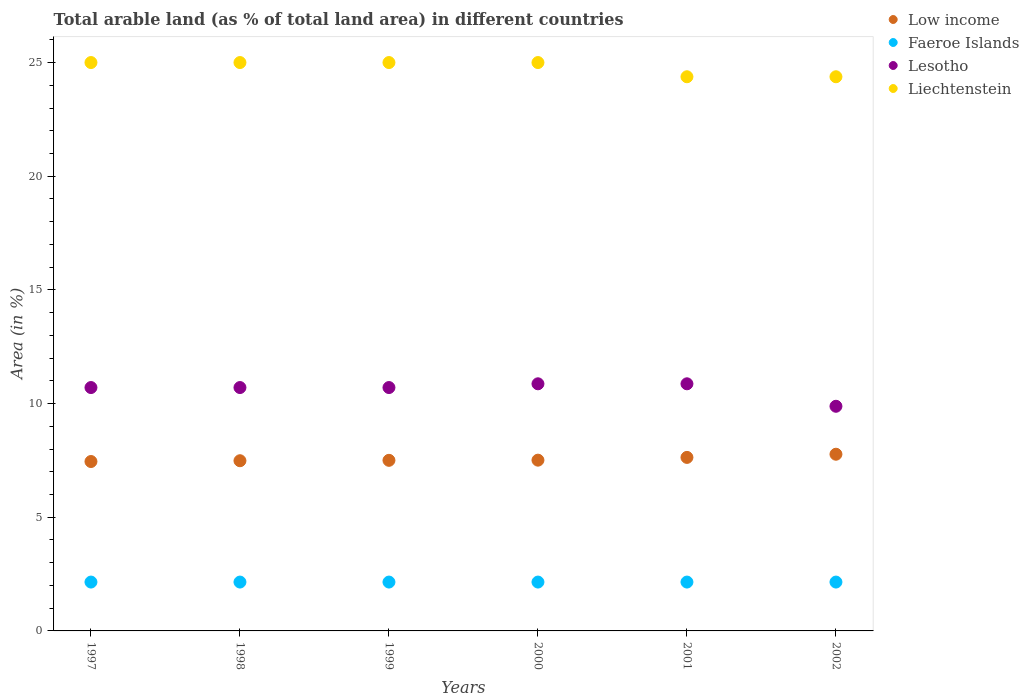How many different coloured dotlines are there?
Offer a terse response. 4. Is the number of dotlines equal to the number of legend labels?
Make the answer very short. Yes. What is the percentage of arable land in Low income in 1998?
Your answer should be compact. 7.49. Across all years, what is the maximum percentage of arable land in Lesotho?
Offer a very short reply. 10.87. Across all years, what is the minimum percentage of arable land in Faeroe Islands?
Your response must be concise. 2.15. In which year was the percentage of arable land in Lesotho maximum?
Offer a terse response. 2000. In which year was the percentage of arable land in Low income minimum?
Your answer should be compact. 1997. What is the total percentage of arable land in Lesotho in the graph?
Your answer should be very brief. 63.74. What is the difference between the percentage of arable land in Low income in 1997 and that in 2001?
Offer a terse response. -0.18. What is the difference between the percentage of arable land in Low income in 1997 and the percentage of arable land in Liechtenstein in 2001?
Provide a short and direct response. -16.92. What is the average percentage of arable land in Lesotho per year?
Provide a succinct answer. 10.62. In the year 1999, what is the difference between the percentage of arable land in Lesotho and percentage of arable land in Faeroe Islands?
Keep it short and to the point. 8.56. In how many years, is the percentage of arable land in Faeroe Islands greater than 16 %?
Offer a terse response. 0. What is the ratio of the percentage of arable land in Low income in 2000 to that in 2001?
Make the answer very short. 0.98. Is the difference between the percentage of arable land in Lesotho in 1998 and 2002 greater than the difference between the percentage of arable land in Faeroe Islands in 1998 and 2002?
Make the answer very short. Yes. What is the difference between the highest and the second highest percentage of arable land in Faeroe Islands?
Offer a terse response. 0. In how many years, is the percentage of arable land in Liechtenstein greater than the average percentage of arable land in Liechtenstein taken over all years?
Offer a very short reply. 4. Is the sum of the percentage of arable land in Liechtenstein in 1999 and 2000 greater than the maximum percentage of arable land in Faeroe Islands across all years?
Give a very brief answer. Yes. Is it the case that in every year, the sum of the percentage of arable land in Low income and percentage of arable land in Faeroe Islands  is greater than the percentage of arable land in Lesotho?
Offer a very short reply. No. Is the percentage of arable land in Faeroe Islands strictly greater than the percentage of arable land in Low income over the years?
Provide a short and direct response. No. Is the percentage of arable land in Low income strictly less than the percentage of arable land in Lesotho over the years?
Ensure brevity in your answer.  Yes. How many years are there in the graph?
Offer a terse response. 6. What is the difference between two consecutive major ticks on the Y-axis?
Provide a succinct answer. 5. Are the values on the major ticks of Y-axis written in scientific E-notation?
Your answer should be very brief. No. Does the graph contain any zero values?
Your answer should be very brief. No. Where does the legend appear in the graph?
Keep it short and to the point. Top right. What is the title of the graph?
Provide a short and direct response. Total arable land (as % of total land area) in different countries. What is the label or title of the X-axis?
Ensure brevity in your answer.  Years. What is the label or title of the Y-axis?
Provide a short and direct response. Area (in %). What is the Area (in %) of Low income in 1997?
Offer a very short reply. 7.45. What is the Area (in %) of Faeroe Islands in 1997?
Your response must be concise. 2.15. What is the Area (in %) of Lesotho in 1997?
Give a very brief answer. 10.7. What is the Area (in %) in Liechtenstein in 1997?
Provide a succinct answer. 25. What is the Area (in %) in Low income in 1998?
Provide a succinct answer. 7.49. What is the Area (in %) of Faeroe Islands in 1998?
Provide a succinct answer. 2.15. What is the Area (in %) in Lesotho in 1998?
Your response must be concise. 10.7. What is the Area (in %) in Liechtenstein in 1998?
Keep it short and to the point. 25. What is the Area (in %) of Low income in 1999?
Provide a short and direct response. 7.5. What is the Area (in %) of Faeroe Islands in 1999?
Your response must be concise. 2.15. What is the Area (in %) of Lesotho in 1999?
Your answer should be very brief. 10.7. What is the Area (in %) in Liechtenstein in 1999?
Your answer should be compact. 25. What is the Area (in %) of Low income in 2000?
Keep it short and to the point. 7.51. What is the Area (in %) in Faeroe Islands in 2000?
Offer a very short reply. 2.15. What is the Area (in %) of Lesotho in 2000?
Offer a terse response. 10.87. What is the Area (in %) in Low income in 2001?
Offer a very short reply. 7.63. What is the Area (in %) of Faeroe Islands in 2001?
Offer a terse response. 2.15. What is the Area (in %) of Lesotho in 2001?
Offer a terse response. 10.87. What is the Area (in %) of Liechtenstein in 2001?
Give a very brief answer. 24.38. What is the Area (in %) of Low income in 2002?
Offer a terse response. 7.77. What is the Area (in %) in Faeroe Islands in 2002?
Provide a short and direct response. 2.15. What is the Area (in %) of Lesotho in 2002?
Your answer should be compact. 9.88. What is the Area (in %) in Liechtenstein in 2002?
Your answer should be very brief. 24.38. Across all years, what is the maximum Area (in %) of Low income?
Ensure brevity in your answer.  7.77. Across all years, what is the maximum Area (in %) in Faeroe Islands?
Keep it short and to the point. 2.15. Across all years, what is the maximum Area (in %) in Lesotho?
Your answer should be very brief. 10.87. Across all years, what is the maximum Area (in %) of Liechtenstein?
Provide a short and direct response. 25. Across all years, what is the minimum Area (in %) in Low income?
Provide a short and direct response. 7.45. Across all years, what is the minimum Area (in %) in Faeroe Islands?
Provide a succinct answer. 2.15. Across all years, what is the minimum Area (in %) of Lesotho?
Your answer should be very brief. 9.88. Across all years, what is the minimum Area (in %) of Liechtenstein?
Give a very brief answer. 24.38. What is the total Area (in %) of Low income in the graph?
Your answer should be compact. 45.36. What is the total Area (in %) of Faeroe Islands in the graph?
Keep it short and to the point. 12.89. What is the total Area (in %) of Lesotho in the graph?
Make the answer very short. 63.74. What is the total Area (in %) in Liechtenstein in the graph?
Provide a succinct answer. 148.75. What is the difference between the Area (in %) of Low income in 1997 and that in 1998?
Offer a very short reply. -0.03. What is the difference between the Area (in %) in Faeroe Islands in 1997 and that in 1998?
Offer a terse response. 0. What is the difference between the Area (in %) of Liechtenstein in 1997 and that in 1998?
Your response must be concise. 0. What is the difference between the Area (in %) of Low income in 1997 and that in 1999?
Give a very brief answer. -0.05. What is the difference between the Area (in %) of Faeroe Islands in 1997 and that in 1999?
Ensure brevity in your answer.  0. What is the difference between the Area (in %) of Low income in 1997 and that in 2000?
Offer a very short reply. -0.06. What is the difference between the Area (in %) of Faeroe Islands in 1997 and that in 2000?
Provide a short and direct response. 0. What is the difference between the Area (in %) of Lesotho in 1997 and that in 2000?
Make the answer very short. -0.16. What is the difference between the Area (in %) in Liechtenstein in 1997 and that in 2000?
Keep it short and to the point. 0. What is the difference between the Area (in %) of Low income in 1997 and that in 2001?
Keep it short and to the point. -0.18. What is the difference between the Area (in %) of Faeroe Islands in 1997 and that in 2001?
Your answer should be compact. 0. What is the difference between the Area (in %) in Lesotho in 1997 and that in 2001?
Keep it short and to the point. -0.16. What is the difference between the Area (in %) of Low income in 1997 and that in 2002?
Offer a terse response. -0.32. What is the difference between the Area (in %) of Lesotho in 1997 and that in 2002?
Give a very brief answer. 0.82. What is the difference between the Area (in %) of Liechtenstein in 1997 and that in 2002?
Your answer should be very brief. 0.62. What is the difference between the Area (in %) in Low income in 1998 and that in 1999?
Your answer should be compact. -0.02. What is the difference between the Area (in %) of Lesotho in 1998 and that in 1999?
Give a very brief answer. 0. What is the difference between the Area (in %) of Liechtenstein in 1998 and that in 1999?
Provide a succinct answer. 0. What is the difference between the Area (in %) of Low income in 1998 and that in 2000?
Offer a terse response. -0.03. What is the difference between the Area (in %) of Faeroe Islands in 1998 and that in 2000?
Your response must be concise. 0. What is the difference between the Area (in %) of Lesotho in 1998 and that in 2000?
Provide a short and direct response. -0.16. What is the difference between the Area (in %) in Liechtenstein in 1998 and that in 2000?
Provide a succinct answer. 0. What is the difference between the Area (in %) of Low income in 1998 and that in 2001?
Ensure brevity in your answer.  -0.15. What is the difference between the Area (in %) in Faeroe Islands in 1998 and that in 2001?
Keep it short and to the point. 0. What is the difference between the Area (in %) in Lesotho in 1998 and that in 2001?
Give a very brief answer. -0.16. What is the difference between the Area (in %) in Liechtenstein in 1998 and that in 2001?
Make the answer very short. 0.62. What is the difference between the Area (in %) in Low income in 1998 and that in 2002?
Provide a short and direct response. -0.29. What is the difference between the Area (in %) of Faeroe Islands in 1998 and that in 2002?
Offer a terse response. 0. What is the difference between the Area (in %) of Lesotho in 1998 and that in 2002?
Your answer should be compact. 0.82. What is the difference between the Area (in %) in Low income in 1999 and that in 2000?
Provide a short and direct response. -0.01. What is the difference between the Area (in %) of Lesotho in 1999 and that in 2000?
Provide a short and direct response. -0.16. What is the difference between the Area (in %) of Low income in 1999 and that in 2001?
Make the answer very short. -0.13. What is the difference between the Area (in %) of Faeroe Islands in 1999 and that in 2001?
Give a very brief answer. 0. What is the difference between the Area (in %) in Lesotho in 1999 and that in 2001?
Keep it short and to the point. -0.16. What is the difference between the Area (in %) of Liechtenstein in 1999 and that in 2001?
Give a very brief answer. 0.62. What is the difference between the Area (in %) of Low income in 1999 and that in 2002?
Give a very brief answer. -0.27. What is the difference between the Area (in %) of Lesotho in 1999 and that in 2002?
Provide a succinct answer. 0.82. What is the difference between the Area (in %) in Low income in 2000 and that in 2001?
Make the answer very short. -0.12. What is the difference between the Area (in %) in Low income in 2000 and that in 2002?
Make the answer very short. -0.26. What is the difference between the Area (in %) in Lesotho in 2000 and that in 2002?
Provide a succinct answer. 0.99. What is the difference between the Area (in %) in Low income in 2001 and that in 2002?
Make the answer very short. -0.14. What is the difference between the Area (in %) of Faeroe Islands in 2001 and that in 2002?
Give a very brief answer. 0. What is the difference between the Area (in %) in Low income in 1997 and the Area (in %) in Faeroe Islands in 1998?
Give a very brief answer. 5.3. What is the difference between the Area (in %) of Low income in 1997 and the Area (in %) of Lesotho in 1998?
Give a very brief answer. -3.25. What is the difference between the Area (in %) of Low income in 1997 and the Area (in %) of Liechtenstein in 1998?
Give a very brief answer. -17.55. What is the difference between the Area (in %) in Faeroe Islands in 1997 and the Area (in %) in Lesotho in 1998?
Your response must be concise. -8.56. What is the difference between the Area (in %) of Faeroe Islands in 1997 and the Area (in %) of Liechtenstein in 1998?
Make the answer very short. -22.85. What is the difference between the Area (in %) in Lesotho in 1997 and the Area (in %) in Liechtenstein in 1998?
Give a very brief answer. -14.3. What is the difference between the Area (in %) in Low income in 1997 and the Area (in %) in Faeroe Islands in 1999?
Provide a succinct answer. 5.3. What is the difference between the Area (in %) of Low income in 1997 and the Area (in %) of Lesotho in 1999?
Ensure brevity in your answer.  -3.25. What is the difference between the Area (in %) of Low income in 1997 and the Area (in %) of Liechtenstein in 1999?
Your response must be concise. -17.55. What is the difference between the Area (in %) of Faeroe Islands in 1997 and the Area (in %) of Lesotho in 1999?
Make the answer very short. -8.56. What is the difference between the Area (in %) in Faeroe Islands in 1997 and the Area (in %) in Liechtenstein in 1999?
Give a very brief answer. -22.85. What is the difference between the Area (in %) of Lesotho in 1997 and the Area (in %) of Liechtenstein in 1999?
Your response must be concise. -14.3. What is the difference between the Area (in %) in Low income in 1997 and the Area (in %) in Faeroe Islands in 2000?
Keep it short and to the point. 5.3. What is the difference between the Area (in %) in Low income in 1997 and the Area (in %) in Lesotho in 2000?
Your answer should be compact. -3.42. What is the difference between the Area (in %) in Low income in 1997 and the Area (in %) in Liechtenstein in 2000?
Make the answer very short. -17.55. What is the difference between the Area (in %) in Faeroe Islands in 1997 and the Area (in %) in Lesotho in 2000?
Give a very brief answer. -8.72. What is the difference between the Area (in %) in Faeroe Islands in 1997 and the Area (in %) in Liechtenstein in 2000?
Make the answer very short. -22.85. What is the difference between the Area (in %) of Lesotho in 1997 and the Area (in %) of Liechtenstein in 2000?
Keep it short and to the point. -14.3. What is the difference between the Area (in %) in Low income in 1997 and the Area (in %) in Faeroe Islands in 2001?
Ensure brevity in your answer.  5.3. What is the difference between the Area (in %) of Low income in 1997 and the Area (in %) of Lesotho in 2001?
Provide a short and direct response. -3.42. What is the difference between the Area (in %) of Low income in 1997 and the Area (in %) of Liechtenstein in 2001?
Offer a terse response. -16.92. What is the difference between the Area (in %) in Faeroe Islands in 1997 and the Area (in %) in Lesotho in 2001?
Provide a succinct answer. -8.72. What is the difference between the Area (in %) in Faeroe Islands in 1997 and the Area (in %) in Liechtenstein in 2001?
Make the answer very short. -22.23. What is the difference between the Area (in %) of Lesotho in 1997 and the Area (in %) of Liechtenstein in 2001?
Provide a short and direct response. -13.67. What is the difference between the Area (in %) of Low income in 1997 and the Area (in %) of Faeroe Islands in 2002?
Make the answer very short. 5.3. What is the difference between the Area (in %) in Low income in 1997 and the Area (in %) in Lesotho in 2002?
Offer a very short reply. -2.43. What is the difference between the Area (in %) in Low income in 1997 and the Area (in %) in Liechtenstein in 2002?
Offer a terse response. -16.92. What is the difference between the Area (in %) in Faeroe Islands in 1997 and the Area (in %) in Lesotho in 2002?
Give a very brief answer. -7.73. What is the difference between the Area (in %) in Faeroe Islands in 1997 and the Area (in %) in Liechtenstein in 2002?
Your answer should be very brief. -22.23. What is the difference between the Area (in %) of Lesotho in 1997 and the Area (in %) of Liechtenstein in 2002?
Give a very brief answer. -13.67. What is the difference between the Area (in %) of Low income in 1998 and the Area (in %) of Faeroe Islands in 1999?
Offer a terse response. 5.34. What is the difference between the Area (in %) in Low income in 1998 and the Area (in %) in Lesotho in 1999?
Your answer should be compact. -3.22. What is the difference between the Area (in %) of Low income in 1998 and the Area (in %) of Liechtenstein in 1999?
Offer a terse response. -17.51. What is the difference between the Area (in %) in Faeroe Islands in 1998 and the Area (in %) in Lesotho in 1999?
Your response must be concise. -8.56. What is the difference between the Area (in %) in Faeroe Islands in 1998 and the Area (in %) in Liechtenstein in 1999?
Provide a short and direct response. -22.85. What is the difference between the Area (in %) of Lesotho in 1998 and the Area (in %) of Liechtenstein in 1999?
Provide a short and direct response. -14.3. What is the difference between the Area (in %) in Low income in 1998 and the Area (in %) in Faeroe Islands in 2000?
Give a very brief answer. 5.34. What is the difference between the Area (in %) of Low income in 1998 and the Area (in %) of Lesotho in 2000?
Make the answer very short. -3.38. What is the difference between the Area (in %) in Low income in 1998 and the Area (in %) in Liechtenstein in 2000?
Keep it short and to the point. -17.51. What is the difference between the Area (in %) of Faeroe Islands in 1998 and the Area (in %) of Lesotho in 2000?
Provide a short and direct response. -8.72. What is the difference between the Area (in %) in Faeroe Islands in 1998 and the Area (in %) in Liechtenstein in 2000?
Provide a short and direct response. -22.85. What is the difference between the Area (in %) of Lesotho in 1998 and the Area (in %) of Liechtenstein in 2000?
Your answer should be very brief. -14.3. What is the difference between the Area (in %) in Low income in 1998 and the Area (in %) in Faeroe Islands in 2001?
Your answer should be very brief. 5.34. What is the difference between the Area (in %) of Low income in 1998 and the Area (in %) of Lesotho in 2001?
Offer a very short reply. -3.38. What is the difference between the Area (in %) in Low income in 1998 and the Area (in %) in Liechtenstein in 2001?
Make the answer very short. -16.89. What is the difference between the Area (in %) of Faeroe Islands in 1998 and the Area (in %) of Lesotho in 2001?
Provide a short and direct response. -8.72. What is the difference between the Area (in %) in Faeroe Islands in 1998 and the Area (in %) in Liechtenstein in 2001?
Offer a very short reply. -22.23. What is the difference between the Area (in %) of Lesotho in 1998 and the Area (in %) of Liechtenstein in 2001?
Ensure brevity in your answer.  -13.67. What is the difference between the Area (in %) of Low income in 1998 and the Area (in %) of Faeroe Islands in 2002?
Your answer should be very brief. 5.34. What is the difference between the Area (in %) in Low income in 1998 and the Area (in %) in Lesotho in 2002?
Offer a very short reply. -2.4. What is the difference between the Area (in %) in Low income in 1998 and the Area (in %) in Liechtenstein in 2002?
Offer a terse response. -16.89. What is the difference between the Area (in %) in Faeroe Islands in 1998 and the Area (in %) in Lesotho in 2002?
Offer a terse response. -7.73. What is the difference between the Area (in %) in Faeroe Islands in 1998 and the Area (in %) in Liechtenstein in 2002?
Offer a terse response. -22.23. What is the difference between the Area (in %) of Lesotho in 1998 and the Area (in %) of Liechtenstein in 2002?
Make the answer very short. -13.67. What is the difference between the Area (in %) in Low income in 1999 and the Area (in %) in Faeroe Islands in 2000?
Provide a succinct answer. 5.35. What is the difference between the Area (in %) in Low income in 1999 and the Area (in %) in Lesotho in 2000?
Give a very brief answer. -3.37. What is the difference between the Area (in %) of Low income in 1999 and the Area (in %) of Liechtenstein in 2000?
Your response must be concise. -17.5. What is the difference between the Area (in %) in Faeroe Islands in 1999 and the Area (in %) in Lesotho in 2000?
Your answer should be compact. -8.72. What is the difference between the Area (in %) in Faeroe Islands in 1999 and the Area (in %) in Liechtenstein in 2000?
Keep it short and to the point. -22.85. What is the difference between the Area (in %) in Lesotho in 1999 and the Area (in %) in Liechtenstein in 2000?
Give a very brief answer. -14.3. What is the difference between the Area (in %) in Low income in 1999 and the Area (in %) in Faeroe Islands in 2001?
Give a very brief answer. 5.35. What is the difference between the Area (in %) of Low income in 1999 and the Area (in %) of Lesotho in 2001?
Make the answer very short. -3.37. What is the difference between the Area (in %) of Low income in 1999 and the Area (in %) of Liechtenstein in 2001?
Your answer should be very brief. -16.87. What is the difference between the Area (in %) in Faeroe Islands in 1999 and the Area (in %) in Lesotho in 2001?
Offer a terse response. -8.72. What is the difference between the Area (in %) of Faeroe Islands in 1999 and the Area (in %) of Liechtenstein in 2001?
Provide a succinct answer. -22.23. What is the difference between the Area (in %) in Lesotho in 1999 and the Area (in %) in Liechtenstein in 2001?
Make the answer very short. -13.67. What is the difference between the Area (in %) in Low income in 1999 and the Area (in %) in Faeroe Islands in 2002?
Give a very brief answer. 5.35. What is the difference between the Area (in %) of Low income in 1999 and the Area (in %) of Lesotho in 2002?
Your answer should be compact. -2.38. What is the difference between the Area (in %) of Low income in 1999 and the Area (in %) of Liechtenstein in 2002?
Offer a terse response. -16.87. What is the difference between the Area (in %) in Faeroe Islands in 1999 and the Area (in %) in Lesotho in 2002?
Your response must be concise. -7.73. What is the difference between the Area (in %) of Faeroe Islands in 1999 and the Area (in %) of Liechtenstein in 2002?
Provide a short and direct response. -22.23. What is the difference between the Area (in %) in Lesotho in 1999 and the Area (in %) in Liechtenstein in 2002?
Ensure brevity in your answer.  -13.67. What is the difference between the Area (in %) of Low income in 2000 and the Area (in %) of Faeroe Islands in 2001?
Provide a succinct answer. 5.36. What is the difference between the Area (in %) in Low income in 2000 and the Area (in %) in Lesotho in 2001?
Offer a very short reply. -3.36. What is the difference between the Area (in %) of Low income in 2000 and the Area (in %) of Liechtenstein in 2001?
Provide a short and direct response. -16.86. What is the difference between the Area (in %) in Faeroe Islands in 2000 and the Area (in %) in Lesotho in 2001?
Offer a very short reply. -8.72. What is the difference between the Area (in %) in Faeroe Islands in 2000 and the Area (in %) in Liechtenstein in 2001?
Your response must be concise. -22.23. What is the difference between the Area (in %) in Lesotho in 2000 and the Area (in %) in Liechtenstein in 2001?
Your answer should be compact. -13.51. What is the difference between the Area (in %) of Low income in 2000 and the Area (in %) of Faeroe Islands in 2002?
Your response must be concise. 5.36. What is the difference between the Area (in %) in Low income in 2000 and the Area (in %) in Lesotho in 2002?
Your answer should be compact. -2.37. What is the difference between the Area (in %) of Low income in 2000 and the Area (in %) of Liechtenstein in 2002?
Provide a succinct answer. -16.86. What is the difference between the Area (in %) in Faeroe Islands in 2000 and the Area (in %) in Lesotho in 2002?
Offer a terse response. -7.73. What is the difference between the Area (in %) of Faeroe Islands in 2000 and the Area (in %) of Liechtenstein in 2002?
Provide a short and direct response. -22.23. What is the difference between the Area (in %) in Lesotho in 2000 and the Area (in %) in Liechtenstein in 2002?
Ensure brevity in your answer.  -13.51. What is the difference between the Area (in %) in Low income in 2001 and the Area (in %) in Faeroe Islands in 2002?
Provide a succinct answer. 5.48. What is the difference between the Area (in %) in Low income in 2001 and the Area (in %) in Lesotho in 2002?
Provide a succinct answer. -2.25. What is the difference between the Area (in %) of Low income in 2001 and the Area (in %) of Liechtenstein in 2002?
Give a very brief answer. -16.74. What is the difference between the Area (in %) of Faeroe Islands in 2001 and the Area (in %) of Lesotho in 2002?
Offer a terse response. -7.73. What is the difference between the Area (in %) of Faeroe Islands in 2001 and the Area (in %) of Liechtenstein in 2002?
Keep it short and to the point. -22.23. What is the difference between the Area (in %) in Lesotho in 2001 and the Area (in %) in Liechtenstein in 2002?
Offer a very short reply. -13.51. What is the average Area (in %) in Low income per year?
Offer a terse response. 7.56. What is the average Area (in %) in Faeroe Islands per year?
Keep it short and to the point. 2.15. What is the average Area (in %) in Lesotho per year?
Provide a short and direct response. 10.62. What is the average Area (in %) of Liechtenstein per year?
Your answer should be compact. 24.79. In the year 1997, what is the difference between the Area (in %) in Low income and Area (in %) in Faeroe Islands?
Your answer should be compact. 5.3. In the year 1997, what is the difference between the Area (in %) in Low income and Area (in %) in Lesotho?
Offer a terse response. -3.25. In the year 1997, what is the difference between the Area (in %) in Low income and Area (in %) in Liechtenstein?
Provide a short and direct response. -17.55. In the year 1997, what is the difference between the Area (in %) in Faeroe Islands and Area (in %) in Lesotho?
Your response must be concise. -8.56. In the year 1997, what is the difference between the Area (in %) in Faeroe Islands and Area (in %) in Liechtenstein?
Offer a terse response. -22.85. In the year 1997, what is the difference between the Area (in %) in Lesotho and Area (in %) in Liechtenstein?
Make the answer very short. -14.3. In the year 1998, what is the difference between the Area (in %) in Low income and Area (in %) in Faeroe Islands?
Make the answer very short. 5.34. In the year 1998, what is the difference between the Area (in %) in Low income and Area (in %) in Lesotho?
Ensure brevity in your answer.  -3.22. In the year 1998, what is the difference between the Area (in %) in Low income and Area (in %) in Liechtenstein?
Your answer should be compact. -17.51. In the year 1998, what is the difference between the Area (in %) in Faeroe Islands and Area (in %) in Lesotho?
Keep it short and to the point. -8.56. In the year 1998, what is the difference between the Area (in %) of Faeroe Islands and Area (in %) of Liechtenstein?
Keep it short and to the point. -22.85. In the year 1998, what is the difference between the Area (in %) in Lesotho and Area (in %) in Liechtenstein?
Make the answer very short. -14.3. In the year 1999, what is the difference between the Area (in %) of Low income and Area (in %) of Faeroe Islands?
Keep it short and to the point. 5.35. In the year 1999, what is the difference between the Area (in %) of Low income and Area (in %) of Lesotho?
Your response must be concise. -3.2. In the year 1999, what is the difference between the Area (in %) of Low income and Area (in %) of Liechtenstein?
Provide a short and direct response. -17.5. In the year 1999, what is the difference between the Area (in %) in Faeroe Islands and Area (in %) in Lesotho?
Ensure brevity in your answer.  -8.56. In the year 1999, what is the difference between the Area (in %) of Faeroe Islands and Area (in %) of Liechtenstein?
Offer a terse response. -22.85. In the year 1999, what is the difference between the Area (in %) in Lesotho and Area (in %) in Liechtenstein?
Your response must be concise. -14.3. In the year 2000, what is the difference between the Area (in %) in Low income and Area (in %) in Faeroe Islands?
Your response must be concise. 5.36. In the year 2000, what is the difference between the Area (in %) of Low income and Area (in %) of Lesotho?
Provide a succinct answer. -3.36. In the year 2000, what is the difference between the Area (in %) of Low income and Area (in %) of Liechtenstein?
Offer a very short reply. -17.49. In the year 2000, what is the difference between the Area (in %) in Faeroe Islands and Area (in %) in Lesotho?
Keep it short and to the point. -8.72. In the year 2000, what is the difference between the Area (in %) in Faeroe Islands and Area (in %) in Liechtenstein?
Provide a succinct answer. -22.85. In the year 2000, what is the difference between the Area (in %) in Lesotho and Area (in %) in Liechtenstein?
Offer a very short reply. -14.13. In the year 2001, what is the difference between the Area (in %) in Low income and Area (in %) in Faeroe Islands?
Ensure brevity in your answer.  5.48. In the year 2001, what is the difference between the Area (in %) in Low income and Area (in %) in Lesotho?
Offer a very short reply. -3.24. In the year 2001, what is the difference between the Area (in %) in Low income and Area (in %) in Liechtenstein?
Make the answer very short. -16.74. In the year 2001, what is the difference between the Area (in %) of Faeroe Islands and Area (in %) of Lesotho?
Your answer should be very brief. -8.72. In the year 2001, what is the difference between the Area (in %) of Faeroe Islands and Area (in %) of Liechtenstein?
Your answer should be very brief. -22.23. In the year 2001, what is the difference between the Area (in %) of Lesotho and Area (in %) of Liechtenstein?
Your answer should be compact. -13.51. In the year 2002, what is the difference between the Area (in %) in Low income and Area (in %) in Faeroe Islands?
Provide a succinct answer. 5.62. In the year 2002, what is the difference between the Area (in %) of Low income and Area (in %) of Lesotho?
Keep it short and to the point. -2.11. In the year 2002, what is the difference between the Area (in %) of Low income and Area (in %) of Liechtenstein?
Give a very brief answer. -16.6. In the year 2002, what is the difference between the Area (in %) of Faeroe Islands and Area (in %) of Lesotho?
Your response must be concise. -7.73. In the year 2002, what is the difference between the Area (in %) of Faeroe Islands and Area (in %) of Liechtenstein?
Provide a short and direct response. -22.23. In the year 2002, what is the difference between the Area (in %) in Lesotho and Area (in %) in Liechtenstein?
Make the answer very short. -14.49. What is the ratio of the Area (in %) in Low income in 1997 to that in 1998?
Give a very brief answer. 1. What is the ratio of the Area (in %) in Faeroe Islands in 1997 to that in 1998?
Keep it short and to the point. 1. What is the ratio of the Area (in %) of Lesotho in 1997 to that in 1998?
Make the answer very short. 1. What is the ratio of the Area (in %) in Liechtenstein in 1997 to that in 1998?
Provide a succinct answer. 1. What is the ratio of the Area (in %) of Faeroe Islands in 1997 to that in 1999?
Provide a short and direct response. 1. What is the ratio of the Area (in %) of Lesotho in 1997 to that in 1999?
Keep it short and to the point. 1. What is the ratio of the Area (in %) in Lesotho in 1997 to that in 2000?
Ensure brevity in your answer.  0.98. What is the ratio of the Area (in %) of Low income in 1997 to that in 2001?
Offer a very short reply. 0.98. What is the ratio of the Area (in %) of Liechtenstein in 1997 to that in 2001?
Offer a terse response. 1.03. What is the ratio of the Area (in %) in Low income in 1997 to that in 2002?
Keep it short and to the point. 0.96. What is the ratio of the Area (in %) of Liechtenstein in 1997 to that in 2002?
Give a very brief answer. 1.03. What is the ratio of the Area (in %) of Low income in 1998 to that in 1999?
Your response must be concise. 1. What is the ratio of the Area (in %) of Faeroe Islands in 1998 to that in 1999?
Offer a very short reply. 1. What is the ratio of the Area (in %) in Liechtenstein in 1998 to that in 1999?
Your response must be concise. 1. What is the ratio of the Area (in %) in Low income in 1998 to that in 2001?
Your response must be concise. 0.98. What is the ratio of the Area (in %) of Faeroe Islands in 1998 to that in 2001?
Offer a terse response. 1. What is the ratio of the Area (in %) of Liechtenstein in 1998 to that in 2001?
Your response must be concise. 1.03. What is the ratio of the Area (in %) in Low income in 1998 to that in 2002?
Your response must be concise. 0.96. What is the ratio of the Area (in %) of Liechtenstein in 1998 to that in 2002?
Make the answer very short. 1.03. What is the ratio of the Area (in %) of Lesotho in 1999 to that in 2000?
Offer a very short reply. 0.98. What is the ratio of the Area (in %) of Liechtenstein in 1999 to that in 2000?
Offer a terse response. 1. What is the ratio of the Area (in %) in Low income in 1999 to that in 2001?
Provide a short and direct response. 0.98. What is the ratio of the Area (in %) in Faeroe Islands in 1999 to that in 2001?
Ensure brevity in your answer.  1. What is the ratio of the Area (in %) in Liechtenstein in 1999 to that in 2001?
Give a very brief answer. 1.03. What is the ratio of the Area (in %) in Low income in 1999 to that in 2002?
Keep it short and to the point. 0.97. What is the ratio of the Area (in %) in Lesotho in 1999 to that in 2002?
Offer a terse response. 1.08. What is the ratio of the Area (in %) of Liechtenstein in 1999 to that in 2002?
Ensure brevity in your answer.  1.03. What is the ratio of the Area (in %) in Low income in 2000 to that in 2001?
Keep it short and to the point. 0.98. What is the ratio of the Area (in %) of Faeroe Islands in 2000 to that in 2001?
Provide a short and direct response. 1. What is the ratio of the Area (in %) in Liechtenstein in 2000 to that in 2001?
Make the answer very short. 1.03. What is the ratio of the Area (in %) in Low income in 2000 to that in 2002?
Your answer should be compact. 0.97. What is the ratio of the Area (in %) in Faeroe Islands in 2000 to that in 2002?
Ensure brevity in your answer.  1. What is the ratio of the Area (in %) in Liechtenstein in 2000 to that in 2002?
Give a very brief answer. 1.03. What is the ratio of the Area (in %) in Low income in 2001 to that in 2002?
Ensure brevity in your answer.  0.98. What is the ratio of the Area (in %) in Faeroe Islands in 2001 to that in 2002?
Provide a succinct answer. 1. What is the ratio of the Area (in %) of Lesotho in 2001 to that in 2002?
Offer a very short reply. 1.1. What is the ratio of the Area (in %) in Liechtenstein in 2001 to that in 2002?
Provide a succinct answer. 1. What is the difference between the highest and the second highest Area (in %) of Low income?
Give a very brief answer. 0.14. What is the difference between the highest and the second highest Area (in %) of Lesotho?
Your answer should be very brief. 0. What is the difference between the highest and the second highest Area (in %) in Liechtenstein?
Ensure brevity in your answer.  0. What is the difference between the highest and the lowest Area (in %) of Low income?
Provide a succinct answer. 0.32. What is the difference between the highest and the lowest Area (in %) of Faeroe Islands?
Ensure brevity in your answer.  0. 